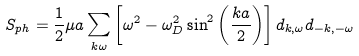<formula> <loc_0><loc_0><loc_500><loc_500>S _ { p h } = \frac { 1 } { 2 } \mu a \sum _ { k \omega } \left [ \omega ^ { 2 } - \omega _ { D } ^ { 2 } \sin ^ { 2 } \left ( \frac { k a } { 2 } \right ) \right ] d _ { k , \omega } d _ { - k , - \omega }</formula> 